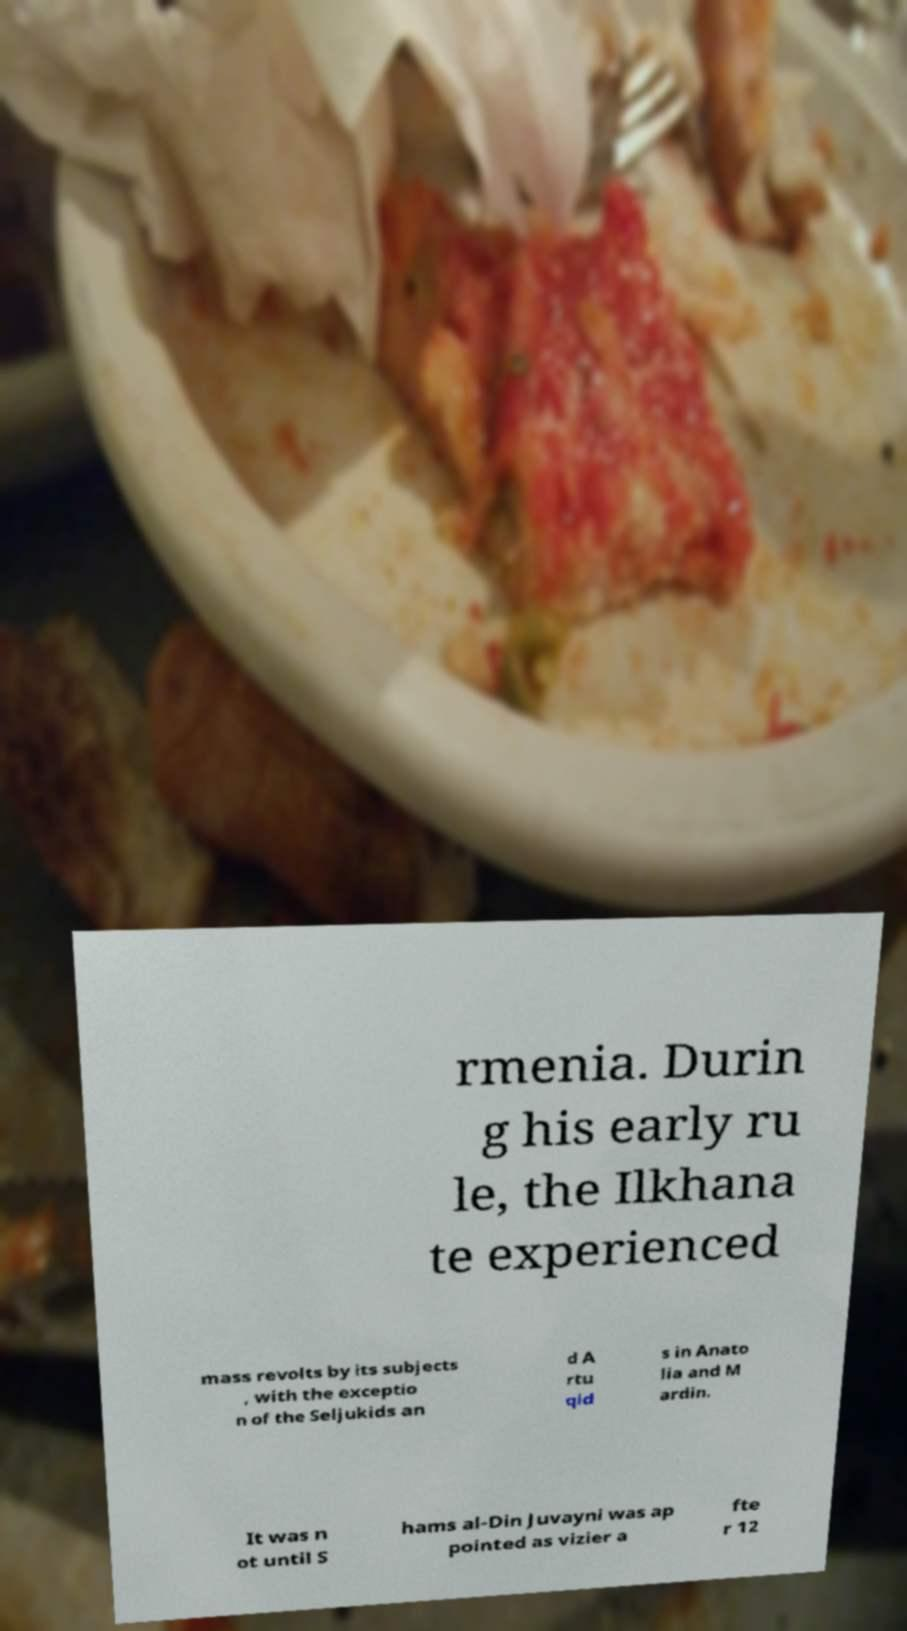Can you read and provide the text displayed in the image?This photo seems to have some interesting text. Can you extract and type it out for me? rmenia. Durin g his early ru le, the Ilkhana te experienced mass revolts by its subjects , with the exceptio n of the Seljukids an d A rtu qid s in Anato lia and M ardin. It was n ot until S hams al-Din Juvayni was ap pointed as vizier a fte r 12 